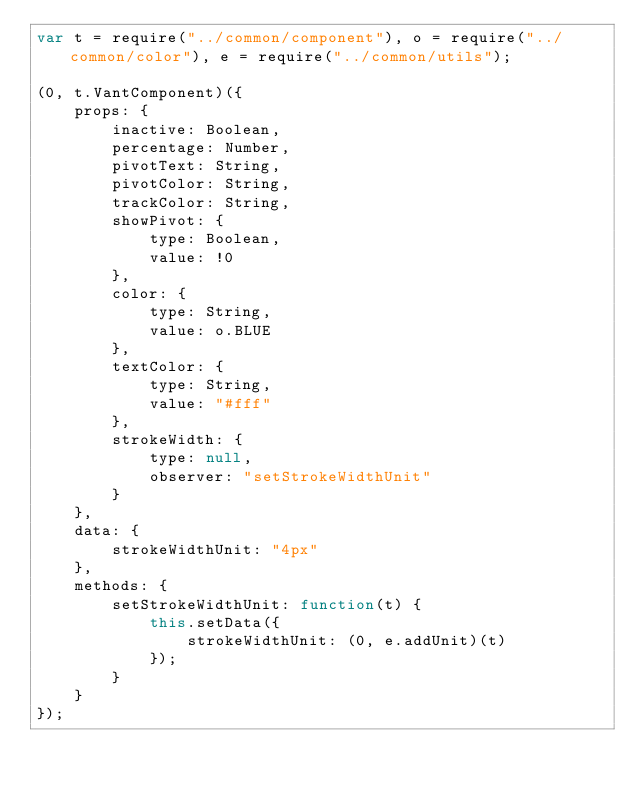<code> <loc_0><loc_0><loc_500><loc_500><_JavaScript_>var t = require("../common/component"), o = require("../common/color"), e = require("../common/utils");

(0, t.VantComponent)({
    props: {
        inactive: Boolean,
        percentage: Number,
        pivotText: String,
        pivotColor: String,
        trackColor: String,
        showPivot: {
            type: Boolean,
            value: !0
        },
        color: {
            type: String,
            value: o.BLUE
        },
        textColor: {
            type: String,
            value: "#fff"
        },
        strokeWidth: {
            type: null,
            observer: "setStrokeWidthUnit"
        }
    },
    data: {
        strokeWidthUnit: "4px"
    },
    methods: {
        setStrokeWidthUnit: function(t) {
            this.setData({
                strokeWidthUnit: (0, e.addUnit)(t)
            });
        }
    }
});</code> 